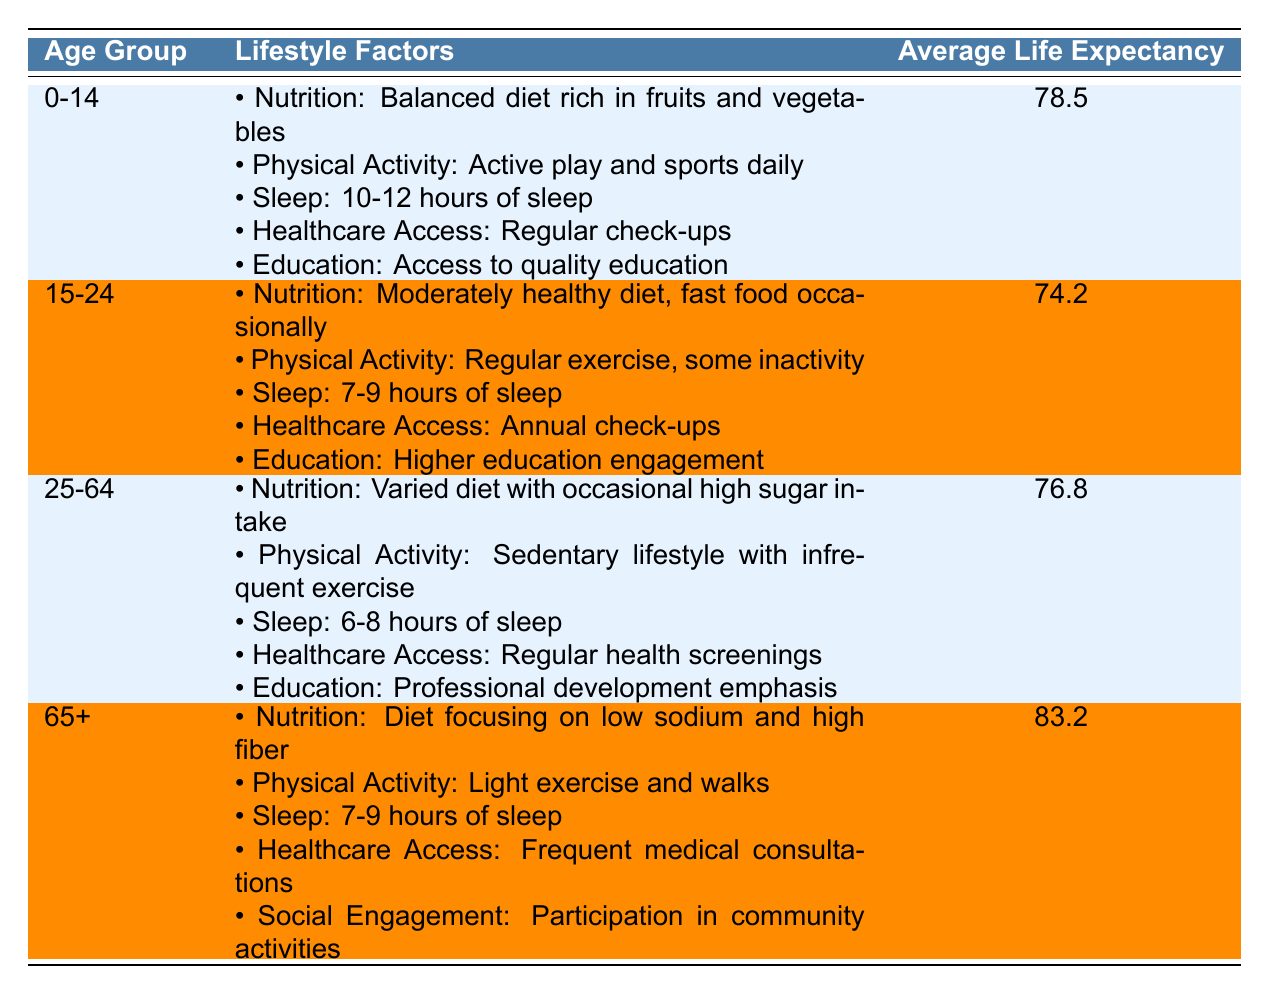What is the average life expectancy for the age group 0-14? The table clearly states that the average life expectancy for the age group 0-14 is 78.5 years.
Answer: 78.5 Which age group has the lowest average life expectancy? By comparing the average life expectancies, 15-24 has the lowest average life expectancy of 74.2 years.
Answer: 15-24 Is the average life expectancy for the age group 25-64 greater than that for 15-24? The average life expectancy for 25-64 is 76.8 years, which is greater than 15-24's 74.2 years, making the statement true.
Answer: Yes What factors does the age group 65+ include under Lifestyle Factors? The age group 65+ includes Nutrition, Physical Activity, Sleep, Healthcare Access, and Social Engagement as its lifestyle factors, emphasizing a nutrient-rich diet and community activities.
Answer: Nutrition, Physical Activity, Sleep, Healthcare Access, Social Engagement What is the difference in average life expectancy between the age groups 0-14 and 65+? The average life expectancy for 0-14 is 78.5 years, while for 65+ it is 83.2 years. The difference is 83.2 - 78.5 = 4.7 years.
Answer: 4.7 years Does the average life expectancy increase consistently with age groups? The average life expectancy does not increase consistently; it decreases from 0-14 to 15-24, then slightly increases for 25-64, and finally increases again for 65+. So, this statement is false.
Answer: No How many lifestyle factors are mentioned for the age group 15-24? The table lists five lifestyle factors for the age group 15-24: Nutrition, Physical Activity, Sleep, Healthcare Access, and Education.
Answer: 5 What can be inferred about the relationship between healthcare access and life expectancy in older adults compared to younger groups? For older adults (65+), there is a focus on frequent medical consultations and participation in community activities, which suggests that healthcare access likely contributes significantly to their higher life expectancy compared to younger groups, where healthcare access is mentioned less frequently.
Answer: Healthcare access is more emphasized in older adults 